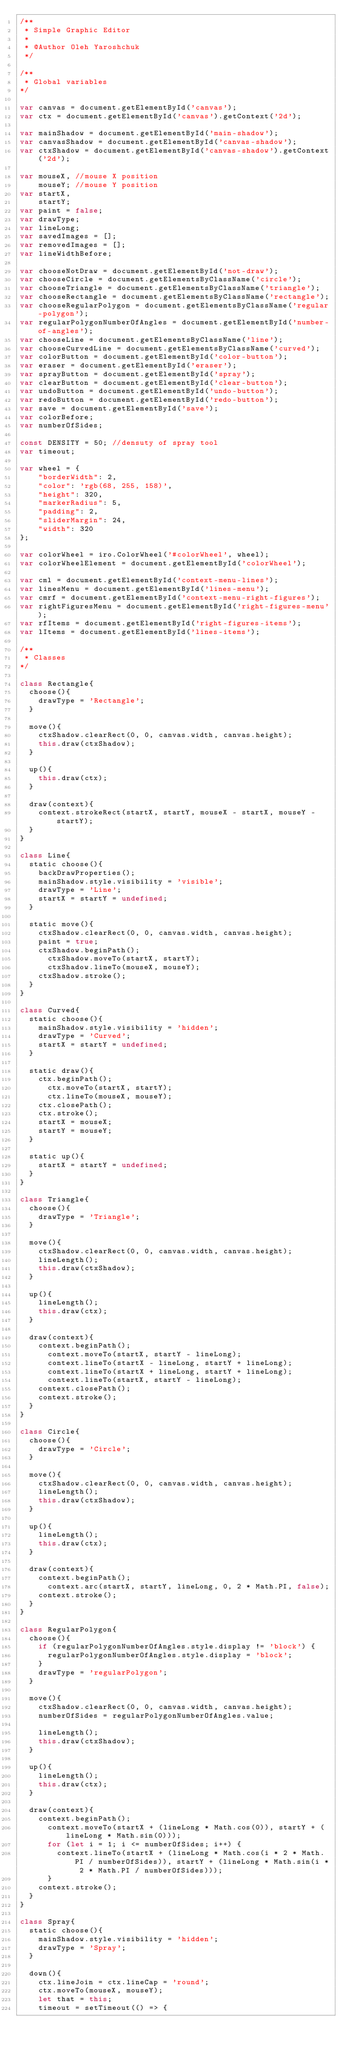Convert code to text. <code><loc_0><loc_0><loc_500><loc_500><_JavaScript_>/**
 * Simple Graphic Editor
 *
 * @Author Oleh Yaroshchuk 
 */

/**
 * Global variables
*/

var canvas = document.getElementById('canvas');
var ctx = document.getElementById('canvas').getContext('2d');

var mainShadow = document.getElementById('main-shadow');
var canvasShadow = document.getElementById('canvas-shadow');
var ctxShadow = document.getElementById('canvas-shadow').getContext('2d');

var mouseX, //mouse X position
    mouseY; //mouse Y position
var startX, 
    startY;
var paint = false;
var drawType; 
var lineLong;
var savedImages = [];
var removedImages = [];
var lineWidthBefore;

var chooseNotDraw = document.getElementById('not-draw');
var chooseCircle = document.getElementsByClassName('circle');
var chooseTriangle = document.getElementsByClassName('triangle');
var chooseRectangle = document.getElementsByClassName('rectangle');
var chooseRegularPolygon = document.getElementsByClassName('regular-polygon');
var regularPolygonNumberOfAngles = document.getElementById('number-of-angles');
var chooseLine = document.getElementsByClassName('line');
var chooseCurvedLine = document.getElementsByClassName('curved');
var colorButton = document.getElementById('color-button');
var eraser = document.getElementById('eraser');
var sprayButton = document.getElementById('spray');
var clearButton = document.getElementById('clear-button');
var undoButton = document.getElementById('undo-button');
var redoButton = document.getElementById('redo-button');
var save = document.getElementById('save');
var colorBefore;
var numberOfSides;

const DENSITY = 50; //densuty of spray tool
var timeout;

var wheel = {
    "borderWidth": 2,
    "color": 'rgb(68, 255, 158)',
    "height": 320,
    "markerRadius": 5,
    "padding": 2,
    "sliderMargin": 24,
    "width": 320
};

var colorWheel = iro.ColorWheel('#colorWheel', wheel);
var colorWheelElement = document.getElementById('colorWheel');

var cml = document.getElementById('context-menu-lines');
var linesMenu = document.getElementById('lines-menu');
var cmrf = document.getElementById('context-menu-right-figures');
var rightFiguresMenu = document.getElementById('right-figures-menu');
var rfItems = document.getElementById('right-figures-items');
var lItems = document.getElementById('lines-items');

/**
 * Classes
*/

class Rectangle{
  choose(){
    drawType = 'Rectangle';
  }

  move(){
    ctxShadow.clearRect(0, 0, canvas.width, canvas.height);
    this.draw(ctxShadow);
  }

  up(){
    this.draw(ctx);
  }

  draw(context){
    context.strokeRect(startX, startY, mouseX - startX, mouseY - startY);
  }
}

class Line{
  static choose(){
    backDrawProperties();
    mainShadow.style.visibility = 'visible'; 
    drawType = 'Line';
    startX = startY = undefined;
  }

  static move(){
    ctxShadow.clearRect(0, 0, canvas.width, canvas.height);
    paint = true;
    ctxShadow.beginPath();
      ctxShadow.moveTo(startX, startY);
      ctxShadow.lineTo(mouseX, mouseY);
    ctxShadow.stroke();
  }
}

class Curved{
  static choose(){
    mainShadow.style.visibility = 'hidden';
    drawType = 'Curved';
    startX = startY = undefined;
  }

  static draw(){
    ctx.beginPath();
      ctx.moveTo(startX, startY);
      ctx.lineTo(mouseX, mouseY);
    ctx.closePath();
    ctx.stroke(); 
    startX = mouseX;
    startY = mouseY;
  }

  static up(){
    startX = startY = undefined;
  }
}

class Triangle{
  choose(){
    drawType = 'Triangle';
  }

  move(){
    ctxShadow.clearRect(0, 0, canvas.width, canvas.height);
    lineLength();
    this.draw(ctxShadow);
  }

  up(){
    lineLength();
    this.draw(ctx);
  }

  draw(context){
    context.beginPath();
      context.moveTo(startX, startY - lineLong);
      context.lineTo(startX - lineLong, startY + lineLong);
      context.lineTo(startX + lineLong, startY + lineLong);
      context.lineTo(startX, startY - lineLong);
    context.closePath();
    context.stroke();
  }
}

class Circle{
  choose(){
    drawType = 'Circle';
  }

  move(){
    ctxShadow.clearRect(0, 0, canvas.width, canvas.height);
    lineLength();
    this.draw(ctxShadow);
  }

  up(){
    lineLength();
    this.draw(ctx);
  }

  draw(context){
    context.beginPath();
      context.arc(startX, startY, lineLong, 0, 2 * Math.PI, false);
    context.stroke();
  }
}

class RegularPolygon{
  choose(){
    if (regularPolygonNumberOfAngles.style.display != 'block') {
      regularPolygonNumberOfAngles.style.display = 'block';
    }
    drawType = 'regularPolygon';
  }

  move(){
    ctxShadow.clearRect(0, 0, canvas.width, canvas.height);
    numberOfSides = regularPolygonNumberOfAngles.value;

    lineLength();
    this.draw(ctxShadow);
  }

  up(){
    lineLength();
    this.draw(ctx);
  }

  draw(context){
    context.beginPath();
      context.moveTo(startX + (lineLong * Math.cos(0)), startY + (lineLong * Math.sin(0)));          
      for (let i = 1; i <= numberOfSides; i++) {
        context.lineTo(startX + (lineLong * Math.cos(i * 2 * Math.PI / numberOfSides)), startY + (lineLong * Math.sin(i * 2 * Math.PI / numberOfSides)));
      }
    context.stroke();
  }
}

class Spray{
  static choose(){
    mainShadow.style.visibility = 'hidden';
    drawType = 'Spray';
  }

  down(){
    ctx.lineJoin = ctx.lineCap = 'round';
    ctx.moveTo(mouseX, mouseY);
    let that = this;
    timeout = setTimeout(() => {</code> 